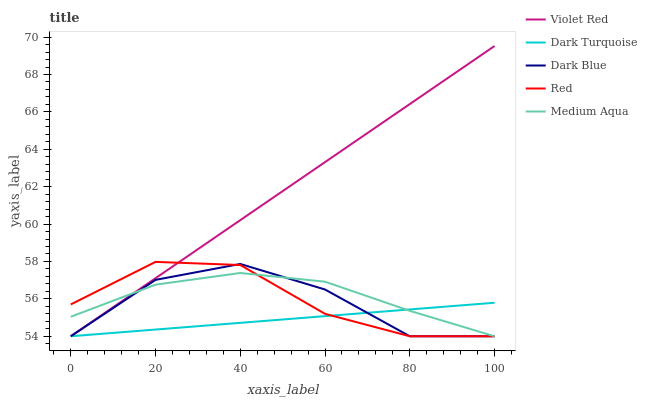Does Dark Turquoise have the minimum area under the curve?
Answer yes or no. Yes. Does Violet Red have the maximum area under the curve?
Answer yes or no. Yes. Does Medium Aqua have the minimum area under the curve?
Answer yes or no. No. Does Medium Aqua have the maximum area under the curve?
Answer yes or no. No. Is Violet Red the smoothest?
Answer yes or no. Yes. Is Dark Blue the roughest?
Answer yes or no. Yes. Is Medium Aqua the smoothest?
Answer yes or no. No. Is Medium Aqua the roughest?
Answer yes or no. No. Does Dark Turquoise have the lowest value?
Answer yes or no. Yes. Does Violet Red have the highest value?
Answer yes or no. Yes. Does Medium Aqua have the highest value?
Answer yes or no. No. Does Red intersect Medium Aqua?
Answer yes or no. Yes. Is Red less than Medium Aqua?
Answer yes or no. No. Is Red greater than Medium Aqua?
Answer yes or no. No. 